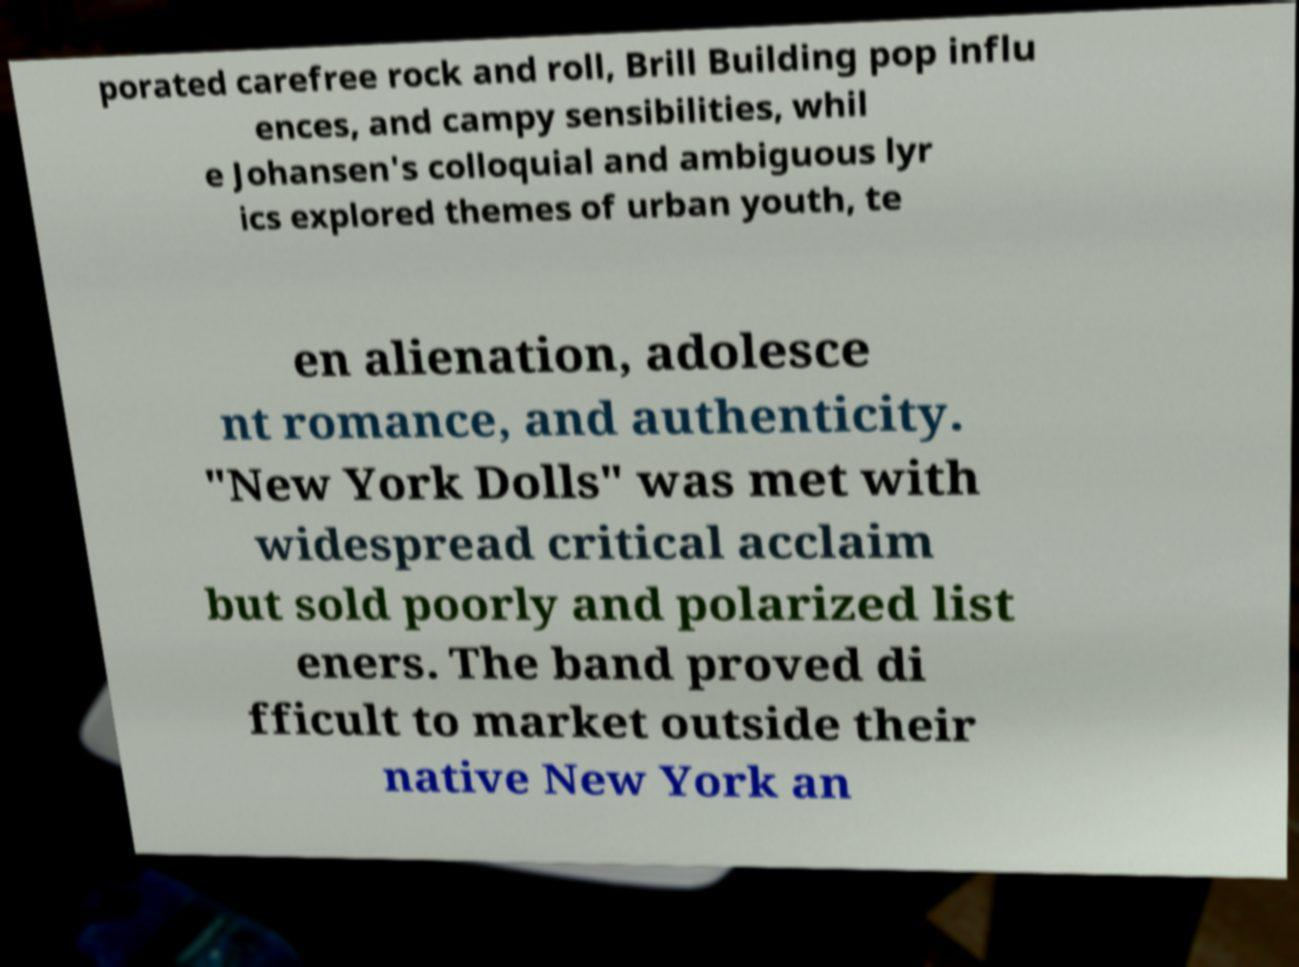Please identify and transcribe the text found in this image. porated carefree rock and roll, Brill Building pop influ ences, and campy sensibilities, whil e Johansen's colloquial and ambiguous lyr ics explored themes of urban youth, te en alienation, adolesce nt romance, and authenticity. "New York Dolls" was met with widespread critical acclaim but sold poorly and polarized list eners. The band proved di fficult to market outside their native New York an 